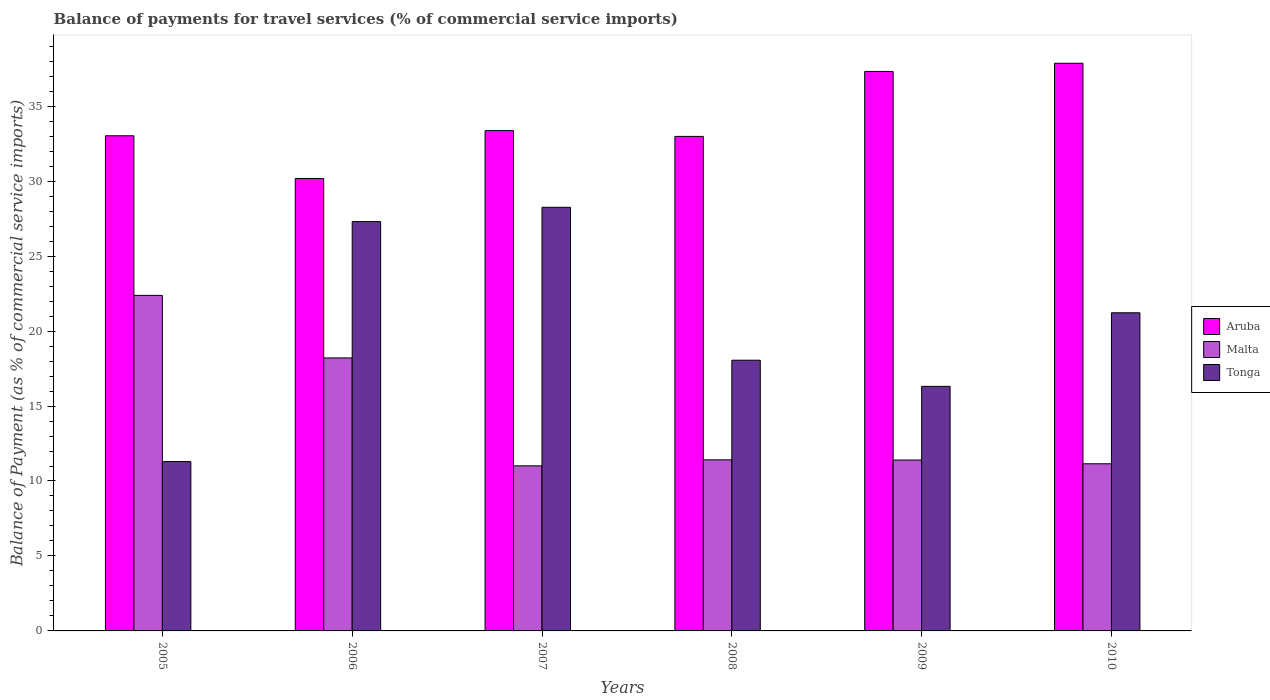How many different coloured bars are there?
Make the answer very short. 3. How many groups of bars are there?
Your answer should be compact. 6. Are the number of bars on each tick of the X-axis equal?
Ensure brevity in your answer.  Yes. How many bars are there on the 1st tick from the left?
Keep it short and to the point. 3. How many bars are there on the 1st tick from the right?
Provide a succinct answer. 3. What is the label of the 3rd group of bars from the left?
Provide a short and direct response. 2007. What is the balance of payments for travel services in Aruba in 2007?
Ensure brevity in your answer.  33.37. Across all years, what is the maximum balance of payments for travel services in Aruba?
Your response must be concise. 37.86. Across all years, what is the minimum balance of payments for travel services in Tonga?
Offer a very short reply. 11.29. What is the total balance of payments for travel services in Tonga in the graph?
Give a very brief answer. 122.44. What is the difference between the balance of payments for travel services in Aruba in 2009 and that in 2010?
Keep it short and to the point. -0.55. What is the difference between the balance of payments for travel services in Tonga in 2005 and the balance of payments for travel services in Malta in 2006?
Offer a very short reply. -6.91. What is the average balance of payments for travel services in Tonga per year?
Ensure brevity in your answer.  20.41. In the year 2009, what is the difference between the balance of payments for travel services in Tonga and balance of payments for travel services in Aruba?
Offer a terse response. -21.01. In how many years, is the balance of payments for travel services in Malta greater than 18 %?
Provide a short and direct response. 2. What is the ratio of the balance of payments for travel services in Tonga in 2005 to that in 2008?
Make the answer very short. 0.63. Is the balance of payments for travel services in Malta in 2008 less than that in 2009?
Make the answer very short. No. Is the difference between the balance of payments for travel services in Tonga in 2007 and 2010 greater than the difference between the balance of payments for travel services in Aruba in 2007 and 2010?
Offer a terse response. Yes. What is the difference between the highest and the second highest balance of payments for travel services in Aruba?
Ensure brevity in your answer.  0.55. What is the difference between the highest and the lowest balance of payments for travel services in Tonga?
Offer a terse response. 16.96. Is the sum of the balance of payments for travel services in Malta in 2006 and 2007 greater than the maximum balance of payments for travel services in Aruba across all years?
Provide a short and direct response. No. What does the 3rd bar from the left in 2006 represents?
Provide a succinct answer. Tonga. What does the 1st bar from the right in 2010 represents?
Give a very brief answer. Tonga. Is it the case that in every year, the sum of the balance of payments for travel services in Tonga and balance of payments for travel services in Malta is greater than the balance of payments for travel services in Aruba?
Offer a very short reply. No. How many bars are there?
Keep it short and to the point. 18. Are all the bars in the graph horizontal?
Provide a succinct answer. No. What is the difference between two consecutive major ticks on the Y-axis?
Provide a succinct answer. 5. Does the graph contain any zero values?
Your response must be concise. No. Does the graph contain grids?
Provide a short and direct response. No. How are the legend labels stacked?
Your response must be concise. Vertical. What is the title of the graph?
Make the answer very short. Balance of payments for travel services (% of commercial service imports). Does "Greece" appear as one of the legend labels in the graph?
Your response must be concise. No. What is the label or title of the X-axis?
Offer a very short reply. Years. What is the label or title of the Y-axis?
Offer a terse response. Balance of Payment (as % of commercial service imports). What is the Balance of Payment (as % of commercial service imports) of Aruba in 2005?
Provide a succinct answer. 33.03. What is the Balance of Payment (as % of commercial service imports) in Malta in 2005?
Provide a short and direct response. 22.38. What is the Balance of Payment (as % of commercial service imports) of Tonga in 2005?
Your answer should be compact. 11.29. What is the Balance of Payment (as % of commercial service imports) in Aruba in 2006?
Your response must be concise. 30.18. What is the Balance of Payment (as % of commercial service imports) in Malta in 2006?
Offer a very short reply. 18.21. What is the Balance of Payment (as % of commercial service imports) in Tonga in 2006?
Your answer should be very brief. 27.3. What is the Balance of Payment (as % of commercial service imports) in Aruba in 2007?
Your answer should be compact. 33.37. What is the Balance of Payment (as % of commercial service imports) of Malta in 2007?
Offer a terse response. 11.01. What is the Balance of Payment (as % of commercial service imports) in Tonga in 2007?
Provide a succinct answer. 28.25. What is the Balance of Payment (as % of commercial service imports) in Aruba in 2008?
Your response must be concise. 32.98. What is the Balance of Payment (as % of commercial service imports) of Malta in 2008?
Offer a very short reply. 11.41. What is the Balance of Payment (as % of commercial service imports) of Tonga in 2008?
Your answer should be very brief. 18.06. What is the Balance of Payment (as % of commercial service imports) in Aruba in 2009?
Ensure brevity in your answer.  37.32. What is the Balance of Payment (as % of commercial service imports) in Malta in 2009?
Provide a short and direct response. 11.4. What is the Balance of Payment (as % of commercial service imports) in Tonga in 2009?
Keep it short and to the point. 16.31. What is the Balance of Payment (as % of commercial service imports) of Aruba in 2010?
Give a very brief answer. 37.86. What is the Balance of Payment (as % of commercial service imports) in Malta in 2010?
Give a very brief answer. 11.15. What is the Balance of Payment (as % of commercial service imports) of Tonga in 2010?
Your answer should be compact. 21.22. Across all years, what is the maximum Balance of Payment (as % of commercial service imports) in Aruba?
Provide a short and direct response. 37.86. Across all years, what is the maximum Balance of Payment (as % of commercial service imports) of Malta?
Ensure brevity in your answer.  22.38. Across all years, what is the maximum Balance of Payment (as % of commercial service imports) in Tonga?
Your response must be concise. 28.25. Across all years, what is the minimum Balance of Payment (as % of commercial service imports) in Aruba?
Your answer should be compact. 30.18. Across all years, what is the minimum Balance of Payment (as % of commercial service imports) of Malta?
Give a very brief answer. 11.01. Across all years, what is the minimum Balance of Payment (as % of commercial service imports) of Tonga?
Make the answer very short. 11.29. What is the total Balance of Payment (as % of commercial service imports) of Aruba in the graph?
Provide a short and direct response. 204.74. What is the total Balance of Payment (as % of commercial service imports) of Malta in the graph?
Offer a terse response. 85.56. What is the total Balance of Payment (as % of commercial service imports) of Tonga in the graph?
Give a very brief answer. 122.44. What is the difference between the Balance of Payment (as % of commercial service imports) of Aruba in 2005 and that in 2006?
Make the answer very short. 2.85. What is the difference between the Balance of Payment (as % of commercial service imports) in Malta in 2005 and that in 2006?
Give a very brief answer. 4.17. What is the difference between the Balance of Payment (as % of commercial service imports) in Tonga in 2005 and that in 2006?
Provide a succinct answer. -16.01. What is the difference between the Balance of Payment (as % of commercial service imports) of Aruba in 2005 and that in 2007?
Give a very brief answer. -0.34. What is the difference between the Balance of Payment (as % of commercial service imports) in Malta in 2005 and that in 2007?
Your response must be concise. 11.37. What is the difference between the Balance of Payment (as % of commercial service imports) in Tonga in 2005 and that in 2007?
Provide a short and direct response. -16.96. What is the difference between the Balance of Payment (as % of commercial service imports) in Aruba in 2005 and that in 2008?
Offer a terse response. 0.04. What is the difference between the Balance of Payment (as % of commercial service imports) of Malta in 2005 and that in 2008?
Offer a terse response. 10.97. What is the difference between the Balance of Payment (as % of commercial service imports) of Tonga in 2005 and that in 2008?
Keep it short and to the point. -6.76. What is the difference between the Balance of Payment (as % of commercial service imports) of Aruba in 2005 and that in 2009?
Give a very brief answer. -4.29. What is the difference between the Balance of Payment (as % of commercial service imports) of Malta in 2005 and that in 2009?
Your response must be concise. 10.98. What is the difference between the Balance of Payment (as % of commercial service imports) of Tonga in 2005 and that in 2009?
Your answer should be compact. -5.02. What is the difference between the Balance of Payment (as % of commercial service imports) in Aruba in 2005 and that in 2010?
Your answer should be very brief. -4.84. What is the difference between the Balance of Payment (as % of commercial service imports) in Malta in 2005 and that in 2010?
Provide a succinct answer. 11.23. What is the difference between the Balance of Payment (as % of commercial service imports) in Tonga in 2005 and that in 2010?
Your response must be concise. -9.93. What is the difference between the Balance of Payment (as % of commercial service imports) in Aruba in 2006 and that in 2007?
Your answer should be compact. -3.19. What is the difference between the Balance of Payment (as % of commercial service imports) of Malta in 2006 and that in 2007?
Provide a short and direct response. 7.2. What is the difference between the Balance of Payment (as % of commercial service imports) in Tonga in 2006 and that in 2007?
Give a very brief answer. -0.95. What is the difference between the Balance of Payment (as % of commercial service imports) of Aruba in 2006 and that in 2008?
Offer a terse response. -2.81. What is the difference between the Balance of Payment (as % of commercial service imports) in Malta in 2006 and that in 2008?
Your response must be concise. 6.8. What is the difference between the Balance of Payment (as % of commercial service imports) in Tonga in 2006 and that in 2008?
Your response must be concise. 9.25. What is the difference between the Balance of Payment (as % of commercial service imports) of Aruba in 2006 and that in 2009?
Give a very brief answer. -7.14. What is the difference between the Balance of Payment (as % of commercial service imports) of Malta in 2006 and that in 2009?
Provide a succinct answer. 6.81. What is the difference between the Balance of Payment (as % of commercial service imports) in Tonga in 2006 and that in 2009?
Provide a succinct answer. 10.99. What is the difference between the Balance of Payment (as % of commercial service imports) in Aruba in 2006 and that in 2010?
Keep it short and to the point. -7.69. What is the difference between the Balance of Payment (as % of commercial service imports) of Malta in 2006 and that in 2010?
Your answer should be very brief. 7.06. What is the difference between the Balance of Payment (as % of commercial service imports) in Tonga in 2006 and that in 2010?
Your answer should be compact. 6.08. What is the difference between the Balance of Payment (as % of commercial service imports) in Aruba in 2007 and that in 2008?
Your answer should be very brief. 0.39. What is the difference between the Balance of Payment (as % of commercial service imports) of Malta in 2007 and that in 2008?
Provide a short and direct response. -0.4. What is the difference between the Balance of Payment (as % of commercial service imports) of Tonga in 2007 and that in 2008?
Offer a terse response. 10.2. What is the difference between the Balance of Payment (as % of commercial service imports) in Aruba in 2007 and that in 2009?
Give a very brief answer. -3.95. What is the difference between the Balance of Payment (as % of commercial service imports) of Malta in 2007 and that in 2009?
Give a very brief answer. -0.39. What is the difference between the Balance of Payment (as % of commercial service imports) of Tonga in 2007 and that in 2009?
Provide a succinct answer. 11.94. What is the difference between the Balance of Payment (as % of commercial service imports) in Aruba in 2007 and that in 2010?
Offer a very short reply. -4.49. What is the difference between the Balance of Payment (as % of commercial service imports) in Malta in 2007 and that in 2010?
Provide a short and direct response. -0.14. What is the difference between the Balance of Payment (as % of commercial service imports) in Tonga in 2007 and that in 2010?
Offer a terse response. 7.03. What is the difference between the Balance of Payment (as % of commercial service imports) in Aruba in 2008 and that in 2009?
Keep it short and to the point. -4.33. What is the difference between the Balance of Payment (as % of commercial service imports) in Malta in 2008 and that in 2009?
Offer a terse response. 0.01. What is the difference between the Balance of Payment (as % of commercial service imports) of Tonga in 2008 and that in 2009?
Ensure brevity in your answer.  1.74. What is the difference between the Balance of Payment (as % of commercial service imports) of Aruba in 2008 and that in 2010?
Ensure brevity in your answer.  -4.88. What is the difference between the Balance of Payment (as % of commercial service imports) of Malta in 2008 and that in 2010?
Provide a succinct answer. 0.26. What is the difference between the Balance of Payment (as % of commercial service imports) of Tonga in 2008 and that in 2010?
Provide a short and direct response. -3.16. What is the difference between the Balance of Payment (as % of commercial service imports) in Aruba in 2009 and that in 2010?
Your answer should be very brief. -0.55. What is the difference between the Balance of Payment (as % of commercial service imports) in Malta in 2009 and that in 2010?
Your response must be concise. 0.25. What is the difference between the Balance of Payment (as % of commercial service imports) in Tonga in 2009 and that in 2010?
Your response must be concise. -4.91. What is the difference between the Balance of Payment (as % of commercial service imports) in Aruba in 2005 and the Balance of Payment (as % of commercial service imports) in Malta in 2006?
Your response must be concise. 14.82. What is the difference between the Balance of Payment (as % of commercial service imports) in Aruba in 2005 and the Balance of Payment (as % of commercial service imports) in Tonga in 2006?
Give a very brief answer. 5.72. What is the difference between the Balance of Payment (as % of commercial service imports) of Malta in 2005 and the Balance of Payment (as % of commercial service imports) of Tonga in 2006?
Make the answer very short. -4.92. What is the difference between the Balance of Payment (as % of commercial service imports) in Aruba in 2005 and the Balance of Payment (as % of commercial service imports) in Malta in 2007?
Make the answer very short. 22.02. What is the difference between the Balance of Payment (as % of commercial service imports) of Aruba in 2005 and the Balance of Payment (as % of commercial service imports) of Tonga in 2007?
Make the answer very short. 4.77. What is the difference between the Balance of Payment (as % of commercial service imports) in Malta in 2005 and the Balance of Payment (as % of commercial service imports) in Tonga in 2007?
Keep it short and to the point. -5.88. What is the difference between the Balance of Payment (as % of commercial service imports) in Aruba in 2005 and the Balance of Payment (as % of commercial service imports) in Malta in 2008?
Provide a succinct answer. 21.61. What is the difference between the Balance of Payment (as % of commercial service imports) in Aruba in 2005 and the Balance of Payment (as % of commercial service imports) in Tonga in 2008?
Offer a very short reply. 14.97. What is the difference between the Balance of Payment (as % of commercial service imports) of Malta in 2005 and the Balance of Payment (as % of commercial service imports) of Tonga in 2008?
Ensure brevity in your answer.  4.32. What is the difference between the Balance of Payment (as % of commercial service imports) in Aruba in 2005 and the Balance of Payment (as % of commercial service imports) in Malta in 2009?
Provide a short and direct response. 21.63. What is the difference between the Balance of Payment (as % of commercial service imports) in Aruba in 2005 and the Balance of Payment (as % of commercial service imports) in Tonga in 2009?
Ensure brevity in your answer.  16.71. What is the difference between the Balance of Payment (as % of commercial service imports) of Malta in 2005 and the Balance of Payment (as % of commercial service imports) of Tonga in 2009?
Ensure brevity in your answer.  6.07. What is the difference between the Balance of Payment (as % of commercial service imports) of Aruba in 2005 and the Balance of Payment (as % of commercial service imports) of Malta in 2010?
Your answer should be very brief. 21.88. What is the difference between the Balance of Payment (as % of commercial service imports) in Aruba in 2005 and the Balance of Payment (as % of commercial service imports) in Tonga in 2010?
Give a very brief answer. 11.81. What is the difference between the Balance of Payment (as % of commercial service imports) in Malta in 2005 and the Balance of Payment (as % of commercial service imports) in Tonga in 2010?
Your response must be concise. 1.16. What is the difference between the Balance of Payment (as % of commercial service imports) in Aruba in 2006 and the Balance of Payment (as % of commercial service imports) in Malta in 2007?
Offer a terse response. 19.17. What is the difference between the Balance of Payment (as % of commercial service imports) in Aruba in 2006 and the Balance of Payment (as % of commercial service imports) in Tonga in 2007?
Your response must be concise. 1.92. What is the difference between the Balance of Payment (as % of commercial service imports) of Malta in 2006 and the Balance of Payment (as % of commercial service imports) of Tonga in 2007?
Provide a succinct answer. -10.05. What is the difference between the Balance of Payment (as % of commercial service imports) in Aruba in 2006 and the Balance of Payment (as % of commercial service imports) in Malta in 2008?
Give a very brief answer. 18.77. What is the difference between the Balance of Payment (as % of commercial service imports) of Aruba in 2006 and the Balance of Payment (as % of commercial service imports) of Tonga in 2008?
Give a very brief answer. 12.12. What is the difference between the Balance of Payment (as % of commercial service imports) of Malta in 2006 and the Balance of Payment (as % of commercial service imports) of Tonga in 2008?
Provide a short and direct response. 0.15. What is the difference between the Balance of Payment (as % of commercial service imports) of Aruba in 2006 and the Balance of Payment (as % of commercial service imports) of Malta in 2009?
Make the answer very short. 18.78. What is the difference between the Balance of Payment (as % of commercial service imports) in Aruba in 2006 and the Balance of Payment (as % of commercial service imports) in Tonga in 2009?
Your answer should be very brief. 13.86. What is the difference between the Balance of Payment (as % of commercial service imports) of Malta in 2006 and the Balance of Payment (as % of commercial service imports) of Tonga in 2009?
Your answer should be very brief. 1.9. What is the difference between the Balance of Payment (as % of commercial service imports) of Aruba in 2006 and the Balance of Payment (as % of commercial service imports) of Malta in 2010?
Keep it short and to the point. 19.03. What is the difference between the Balance of Payment (as % of commercial service imports) of Aruba in 2006 and the Balance of Payment (as % of commercial service imports) of Tonga in 2010?
Your response must be concise. 8.96. What is the difference between the Balance of Payment (as % of commercial service imports) in Malta in 2006 and the Balance of Payment (as % of commercial service imports) in Tonga in 2010?
Provide a short and direct response. -3.01. What is the difference between the Balance of Payment (as % of commercial service imports) of Aruba in 2007 and the Balance of Payment (as % of commercial service imports) of Malta in 2008?
Ensure brevity in your answer.  21.96. What is the difference between the Balance of Payment (as % of commercial service imports) of Aruba in 2007 and the Balance of Payment (as % of commercial service imports) of Tonga in 2008?
Your response must be concise. 15.31. What is the difference between the Balance of Payment (as % of commercial service imports) of Malta in 2007 and the Balance of Payment (as % of commercial service imports) of Tonga in 2008?
Give a very brief answer. -7.05. What is the difference between the Balance of Payment (as % of commercial service imports) in Aruba in 2007 and the Balance of Payment (as % of commercial service imports) in Malta in 2009?
Make the answer very short. 21.97. What is the difference between the Balance of Payment (as % of commercial service imports) in Aruba in 2007 and the Balance of Payment (as % of commercial service imports) in Tonga in 2009?
Keep it short and to the point. 17.06. What is the difference between the Balance of Payment (as % of commercial service imports) in Malta in 2007 and the Balance of Payment (as % of commercial service imports) in Tonga in 2009?
Provide a succinct answer. -5.3. What is the difference between the Balance of Payment (as % of commercial service imports) in Aruba in 2007 and the Balance of Payment (as % of commercial service imports) in Malta in 2010?
Your answer should be very brief. 22.22. What is the difference between the Balance of Payment (as % of commercial service imports) in Aruba in 2007 and the Balance of Payment (as % of commercial service imports) in Tonga in 2010?
Ensure brevity in your answer.  12.15. What is the difference between the Balance of Payment (as % of commercial service imports) of Malta in 2007 and the Balance of Payment (as % of commercial service imports) of Tonga in 2010?
Your response must be concise. -10.21. What is the difference between the Balance of Payment (as % of commercial service imports) of Aruba in 2008 and the Balance of Payment (as % of commercial service imports) of Malta in 2009?
Keep it short and to the point. 21.59. What is the difference between the Balance of Payment (as % of commercial service imports) of Aruba in 2008 and the Balance of Payment (as % of commercial service imports) of Tonga in 2009?
Offer a terse response. 16.67. What is the difference between the Balance of Payment (as % of commercial service imports) in Malta in 2008 and the Balance of Payment (as % of commercial service imports) in Tonga in 2009?
Keep it short and to the point. -4.9. What is the difference between the Balance of Payment (as % of commercial service imports) of Aruba in 2008 and the Balance of Payment (as % of commercial service imports) of Malta in 2010?
Offer a terse response. 21.84. What is the difference between the Balance of Payment (as % of commercial service imports) in Aruba in 2008 and the Balance of Payment (as % of commercial service imports) in Tonga in 2010?
Your response must be concise. 11.76. What is the difference between the Balance of Payment (as % of commercial service imports) in Malta in 2008 and the Balance of Payment (as % of commercial service imports) in Tonga in 2010?
Offer a very short reply. -9.81. What is the difference between the Balance of Payment (as % of commercial service imports) of Aruba in 2009 and the Balance of Payment (as % of commercial service imports) of Malta in 2010?
Keep it short and to the point. 26.17. What is the difference between the Balance of Payment (as % of commercial service imports) in Aruba in 2009 and the Balance of Payment (as % of commercial service imports) in Tonga in 2010?
Your answer should be very brief. 16.1. What is the difference between the Balance of Payment (as % of commercial service imports) in Malta in 2009 and the Balance of Payment (as % of commercial service imports) in Tonga in 2010?
Provide a succinct answer. -9.82. What is the average Balance of Payment (as % of commercial service imports) of Aruba per year?
Your answer should be compact. 34.12. What is the average Balance of Payment (as % of commercial service imports) of Malta per year?
Your response must be concise. 14.26. What is the average Balance of Payment (as % of commercial service imports) of Tonga per year?
Your answer should be compact. 20.41. In the year 2005, what is the difference between the Balance of Payment (as % of commercial service imports) of Aruba and Balance of Payment (as % of commercial service imports) of Malta?
Provide a succinct answer. 10.65. In the year 2005, what is the difference between the Balance of Payment (as % of commercial service imports) of Aruba and Balance of Payment (as % of commercial service imports) of Tonga?
Your answer should be very brief. 21.73. In the year 2005, what is the difference between the Balance of Payment (as % of commercial service imports) of Malta and Balance of Payment (as % of commercial service imports) of Tonga?
Offer a terse response. 11.09. In the year 2006, what is the difference between the Balance of Payment (as % of commercial service imports) in Aruba and Balance of Payment (as % of commercial service imports) in Malta?
Ensure brevity in your answer.  11.97. In the year 2006, what is the difference between the Balance of Payment (as % of commercial service imports) in Aruba and Balance of Payment (as % of commercial service imports) in Tonga?
Offer a very short reply. 2.87. In the year 2006, what is the difference between the Balance of Payment (as % of commercial service imports) in Malta and Balance of Payment (as % of commercial service imports) in Tonga?
Provide a succinct answer. -9.09. In the year 2007, what is the difference between the Balance of Payment (as % of commercial service imports) in Aruba and Balance of Payment (as % of commercial service imports) in Malta?
Provide a succinct answer. 22.36. In the year 2007, what is the difference between the Balance of Payment (as % of commercial service imports) in Aruba and Balance of Payment (as % of commercial service imports) in Tonga?
Ensure brevity in your answer.  5.12. In the year 2007, what is the difference between the Balance of Payment (as % of commercial service imports) of Malta and Balance of Payment (as % of commercial service imports) of Tonga?
Provide a succinct answer. -17.24. In the year 2008, what is the difference between the Balance of Payment (as % of commercial service imports) of Aruba and Balance of Payment (as % of commercial service imports) of Malta?
Your response must be concise. 21.57. In the year 2008, what is the difference between the Balance of Payment (as % of commercial service imports) of Aruba and Balance of Payment (as % of commercial service imports) of Tonga?
Provide a short and direct response. 14.93. In the year 2008, what is the difference between the Balance of Payment (as % of commercial service imports) in Malta and Balance of Payment (as % of commercial service imports) in Tonga?
Provide a short and direct response. -6.65. In the year 2009, what is the difference between the Balance of Payment (as % of commercial service imports) in Aruba and Balance of Payment (as % of commercial service imports) in Malta?
Provide a short and direct response. 25.92. In the year 2009, what is the difference between the Balance of Payment (as % of commercial service imports) in Aruba and Balance of Payment (as % of commercial service imports) in Tonga?
Your answer should be compact. 21.01. In the year 2009, what is the difference between the Balance of Payment (as % of commercial service imports) of Malta and Balance of Payment (as % of commercial service imports) of Tonga?
Give a very brief answer. -4.91. In the year 2010, what is the difference between the Balance of Payment (as % of commercial service imports) in Aruba and Balance of Payment (as % of commercial service imports) in Malta?
Provide a succinct answer. 26.71. In the year 2010, what is the difference between the Balance of Payment (as % of commercial service imports) of Aruba and Balance of Payment (as % of commercial service imports) of Tonga?
Give a very brief answer. 16.64. In the year 2010, what is the difference between the Balance of Payment (as % of commercial service imports) in Malta and Balance of Payment (as % of commercial service imports) in Tonga?
Ensure brevity in your answer.  -10.07. What is the ratio of the Balance of Payment (as % of commercial service imports) of Aruba in 2005 to that in 2006?
Ensure brevity in your answer.  1.09. What is the ratio of the Balance of Payment (as % of commercial service imports) in Malta in 2005 to that in 2006?
Your response must be concise. 1.23. What is the ratio of the Balance of Payment (as % of commercial service imports) of Tonga in 2005 to that in 2006?
Offer a terse response. 0.41. What is the ratio of the Balance of Payment (as % of commercial service imports) of Malta in 2005 to that in 2007?
Your response must be concise. 2.03. What is the ratio of the Balance of Payment (as % of commercial service imports) of Tonga in 2005 to that in 2007?
Offer a very short reply. 0.4. What is the ratio of the Balance of Payment (as % of commercial service imports) of Aruba in 2005 to that in 2008?
Your answer should be compact. 1. What is the ratio of the Balance of Payment (as % of commercial service imports) in Malta in 2005 to that in 2008?
Give a very brief answer. 1.96. What is the ratio of the Balance of Payment (as % of commercial service imports) of Tonga in 2005 to that in 2008?
Give a very brief answer. 0.63. What is the ratio of the Balance of Payment (as % of commercial service imports) of Aruba in 2005 to that in 2009?
Your response must be concise. 0.89. What is the ratio of the Balance of Payment (as % of commercial service imports) of Malta in 2005 to that in 2009?
Provide a short and direct response. 1.96. What is the ratio of the Balance of Payment (as % of commercial service imports) in Tonga in 2005 to that in 2009?
Give a very brief answer. 0.69. What is the ratio of the Balance of Payment (as % of commercial service imports) of Aruba in 2005 to that in 2010?
Provide a short and direct response. 0.87. What is the ratio of the Balance of Payment (as % of commercial service imports) of Malta in 2005 to that in 2010?
Ensure brevity in your answer.  2.01. What is the ratio of the Balance of Payment (as % of commercial service imports) of Tonga in 2005 to that in 2010?
Your answer should be very brief. 0.53. What is the ratio of the Balance of Payment (as % of commercial service imports) in Aruba in 2006 to that in 2007?
Ensure brevity in your answer.  0.9. What is the ratio of the Balance of Payment (as % of commercial service imports) of Malta in 2006 to that in 2007?
Give a very brief answer. 1.65. What is the ratio of the Balance of Payment (as % of commercial service imports) in Tonga in 2006 to that in 2007?
Offer a very short reply. 0.97. What is the ratio of the Balance of Payment (as % of commercial service imports) of Aruba in 2006 to that in 2008?
Ensure brevity in your answer.  0.91. What is the ratio of the Balance of Payment (as % of commercial service imports) in Malta in 2006 to that in 2008?
Keep it short and to the point. 1.6. What is the ratio of the Balance of Payment (as % of commercial service imports) in Tonga in 2006 to that in 2008?
Your answer should be compact. 1.51. What is the ratio of the Balance of Payment (as % of commercial service imports) in Aruba in 2006 to that in 2009?
Your response must be concise. 0.81. What is the ratio of the Balance of Payment (as % of commercial service imports) of Malta in 2006 to that in 2009?
Your answer should be very brief. 1.6. What is the ratio of the Balance of Payment (as % of commercial service imports) of Tonga in 2006 to that in 2009?
Give a very brief answer. 1.67. What is the ratio of the Balance of Payment (as % of commercial service imports) of Aruba in 2006 to that in 2010?
Give a very brief answer. 0.8. What is the ratio of the Balance of Payment (as % of commercial service imports) of Malta in 2006 to that in 2010?
Keep it short and to the point. 1.63. What is the ratio of the Balance of Payment (as % of commercial service imports) in Tonga in 2006 to that in 2010?
Provide a succinct answer. 1.29. What is the ratio of the Balance of Payment (as % of commercial service imports) of Aruba in 2007 to that in 2008?
Your answer should be compact. 1.01. What is the ratio of the Balance of Payment (as % of commercial service imports) of Malta in 2007 to that in 2008?
Provide a short and direct response. 0.96. What is the ratio of the Balance of Payment (as % of commercial service imports) in Tonga in 2007 to that in 2008?
Your response must be concise. 1.56. What is the ratio of the Balance of Payment (as % of commercial service imports) in Aruba in 2007 to that in 2009?
Ensure brevity in your answer.  0.89. What is the ratio of the Balance of Payment (as % of commercial service imports) in Malta in 2007 to that in 2009?
Your answer should be very brief. 0.97. What is the ratio of the Balance of Payment (as % of commercial service imports) in Tonga in 2007 to that in 2009?
Offer a terse response. 1.73. What is the ratio of the Balance of Payment (as % of commercial service imports) in Aruba in 2007 to that in 2010?
Provide a short and direct response. 0.88. What is the ratio of the Balance of Payment (as % of commercial service imports) of Malta in 2007 to that in 2010?
Offer a very short reply. 0.99. What is the ratio of the Balance of Payment (as % of commercial service imports) in Tonga in 2007 to that in 2010?
Provide a succinct answer. 1.33. What is the ratio of the Balance of Payment (as % of commercial service imports) in Aruba in 2008 to that in 2009?
Keep it short and to the point. 0.88. What is the ratio of the Balance of Payment (as % of commercial service imports) in Malta in 2008 to that in 2009?
Offer a terse response. 1. What is the ratio of the Balance of Payment (as % of commercial service imports) in Tonga in 2008 to that in 2009?
Keep it short and to the point. 1.11. What is the ratio of the Balance of Payment (as % of commercial service imports) of Aruba in 2008 to that in 2010?
Your answer should be very brief. 0.87. What is the ratio of the Balance of Payment (as % of commercial service imports) in Malta in 2008 to that in 2010?
Give a very brief answer. 1.02. What is the ratio of the Balance of Payment (as % of commercial service imports) in Tonga in 2008 to that in 2010?
Your answer should be compact. 0.85. What is the ratio of the Balance of Payment (as % of commercial service imports) in Aruba in 2009 to that in 2010?
Your answer should be very brief. 0.99. What is the ratio of the Balance of Payment (as % of commercial service imports) of Malta in 2009 to that in 2010?
Provide a short and direct response. 1.02. What is the ratio of the Balance of Payment (as % of commercial service imports) of Tonga in 2009 to that in 2010?
Provide a short and direct response. 0.77. What is the difference between the highest and the second highest Balance of Payment (as % of commercial service imports) in Aruba?
Your answer should be very brief. 0.55. What is the difference between the highest and the second highest Balance of Payment (as % of commercial service imports) in Malta?
Give a very brief answer. 4.17. What is the difference between the highest and the second highest Balance of Payment (as % of commercial service imports) of Tonga?
Ensure brevity in your answer.  0.95. What is the difference between the highest and the lowest Balance of Payment (as % of commercial service imports) of Aruba?
Provide a short and direct response. 7.69. What is the difference between the highest and the lowest Balance of Payment (as % of commercial service imports) in Malta?
Provide a short and direct response. 11.37. What is the difference between the highest and the lowest Balance of Payment (as % of commercial service imports) in Tonga?
Give a very brief answer. 16.96. 